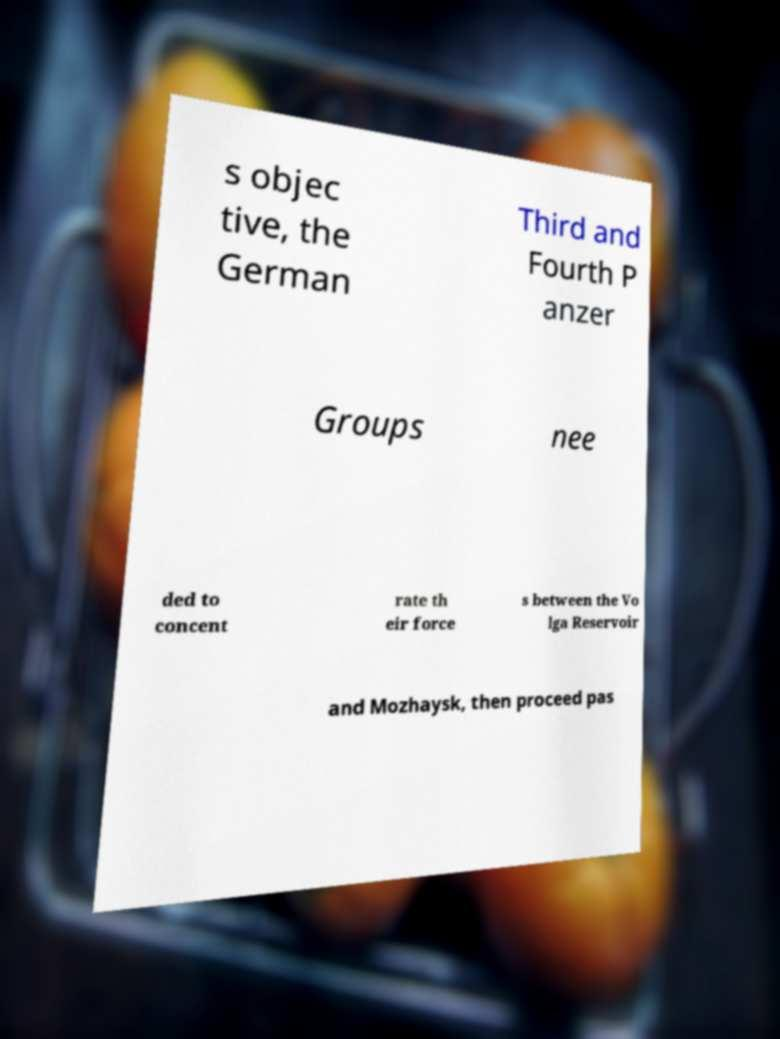Could you assist in decoding the text presented in this image and type it out clearly? s objec tive, the German Third and Fourth P anzer Groups nee ded to concent rate th eir force s between the Vo lga Reservoir and Mozhaysk, then proceed pas 